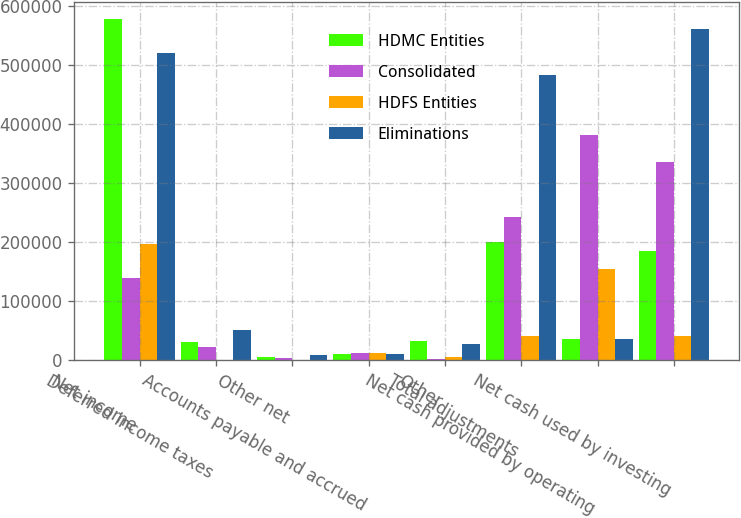Convert chart to OTSL. <chart><loc_0><loc_0><loc_500><loc_500><stacked_bar_chart><ecel><fcel>Net income<fcel>Deferred income taxes<fcel>Other net<fcel>Accounts payable and accrued<fcel>Other<fcel>Total adjustments<fcel>Net cash provided by operating<fcel>Net cash used by investing<nl><fcel>HDMC Entities<fcel>578727<fcel>29949<fcel>4858<fcel>9753<fcel>31868<fcel>199588<fcel>36291.5<fcel>185741<nl><fcel>Consolidated<fcel>139234<fcel>21497<fcel>3498<fcel>11497<fcel>1684<fcel>242797<fcel>382031<fcel>336012<nl><fcel>HDFS Entities<fcel>196202<fcel>591<fcel>203<fcel>11872<fcel>5618<fcel>40917<fcel>155285<fcel>40715<nl><fcel>Eliminations<fcel>521759<fcel>50855<fcel>8559<fcel>10128<fcel>27934<fcel>483302<fcel>36291.5<fcel>562468<nl></chart> 